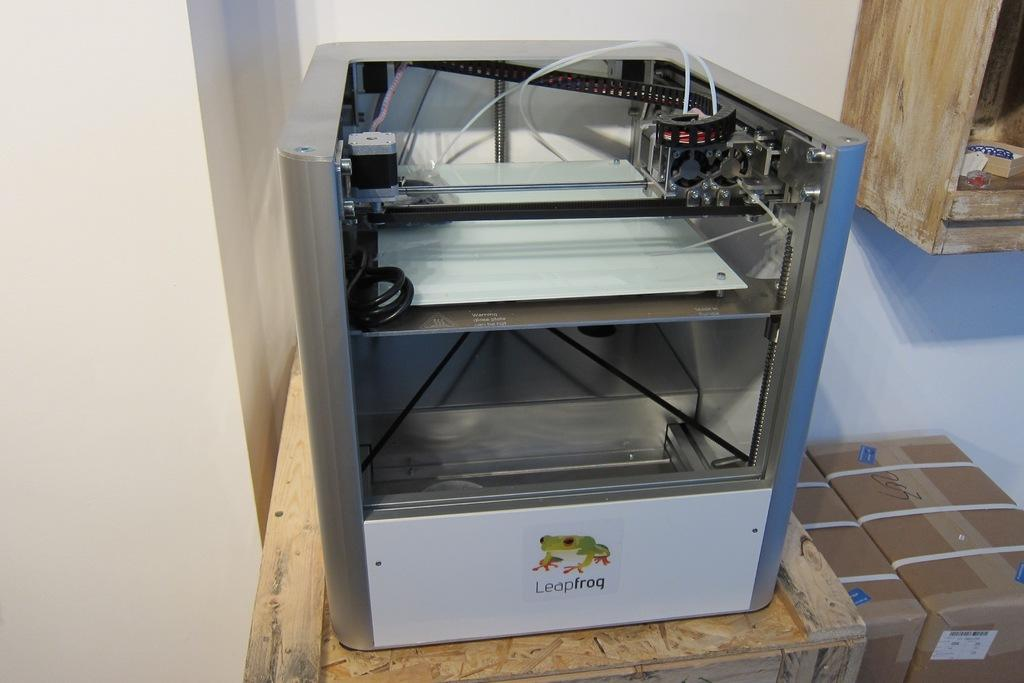<image>
Relay a brief, clear account of the picture shown. a large machine with a frog on it and the text 'leapfrog' 